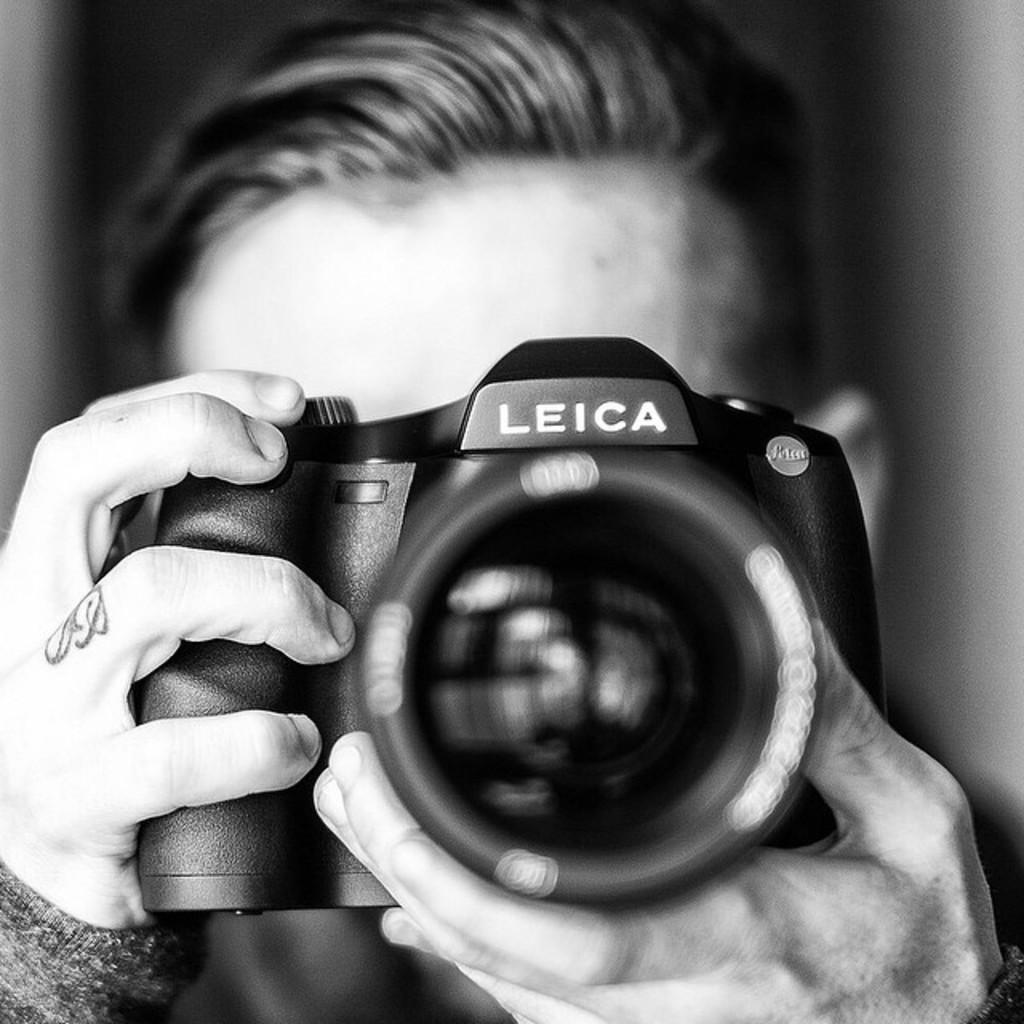What is the man in the image doing? The man is holding a camera in the image. What might the man be interested in capturing with the camera? It is not clear what the man is trying to capture, but he is holding a camera, which suggests he is interested in taking photos. Can you describe the background of the image? There might be a door in the background of the image. What type of quiver can be seen on the man's back in the image? There is no quiver visible on the man's back in the image. Can you describe the goldfish swimming in the water near the man in the image? There are no goldfish present in the image. 